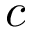Convert formula to latex. <formula><loc_0><loc_0><loc_500><loc_500>c</formula> 